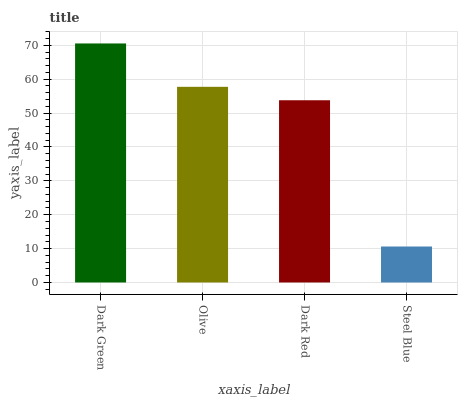Is Steel Blue the minimum?
Answer yes or no. Yes. Is Dark Green the maximum?
Answer yes or no. Yes. Is Olive the minimum?
Answer yes or no. No. Is Olive the maximum?
Answer yes or no. No. Is Dark Green greater than Olive?
Answer yes or no. Yes. Is Olive less than Dark Green?
Answer yes or no. Yes. Is Olive greater than Dark Green?
Answer yes or no. No. Is Dark Green less than Olive?
Answer yes or no. No. Is Olive the high median?
Answer yes or no. Yes. Is Dark Red the low median?
Answer yes or no. Yes. Is Dark Red the high median?
Answer yes or no. No. Is Olive the low median?
Answer yes or no. No. 